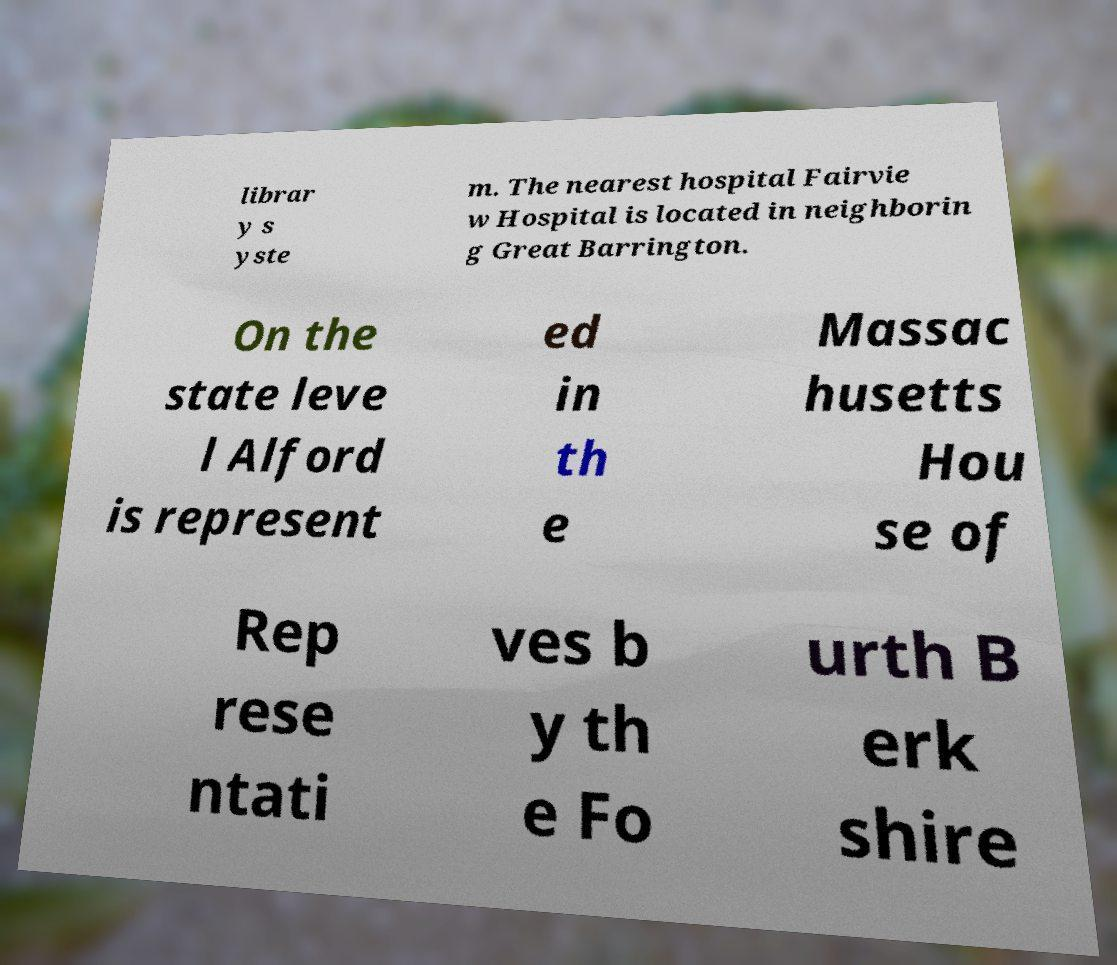Could you extract and type out the text from this image? librar y s yste m. The nearest hospital Fairvie w Hospital is located in neighborin g Great Barrington. On the state leve l Alford is represent ed in th e Massac husetts Hou se of Rep rese ntati ves b y th e Fo urth B erk shire 